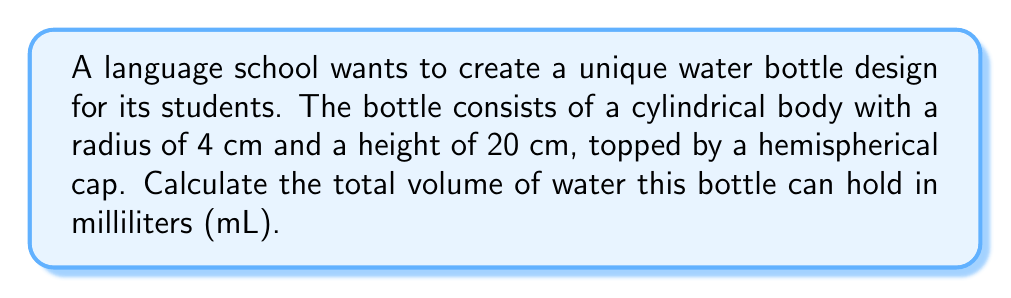What is the answer to this math problem? Let's break this down step-by-step:

1) First, we need to calculate the volume of the cylindrical body:
   The formula for the volume of a cylinder is $V_{cylinder} = \pi r^2 h$
   where $r$ is the radius and $h$ is the height.

   $V_{cylinder} = \pi (4 \text{ cm})^2 (20 \text{ cm})$
   $V_{cylinder} = 16\pi \times 20 = 320\pi \text{ cm}^3$

2) Next, we calculate the volume of the hemispherical cap:
   The formula for the volume of a hemisphere is $V_{hemisphere} = \frac{2}{3}\pi r^3$

   $V_{hemisphere} = \frac{2}{3}\pi (4 \text{ cm})^3$
   $V_{hemisphere} = \frac{2}{3}\pi \times 64 = \frac{128}{3}\pi \text{ cm}^3$

3) The total volume is the sum of these two parts:
   $V_{total} = V_{cylinder} + V_{hemisphere}$
   $V_{total} = 320\pi \text{ cm}^3 + \frac{128}{3}\pi \text{ cm}^3$
   $V_{total} = (320 + \frac{128}{3})\pi \text{ cm}^3$
   $V_{total} = \frac{1088}{3}\pi \text{ cm}^3$

4) To convert cubic centimeters to milliliters, we multiply by 1 (since 1 cm³ = 1 mL):
   $V_{total} = \frac{1088}{3}\pi \text{ mL} \approx 1137.35 \text{ mL}$
Answer: $1137.35 \text{ mL}$ 